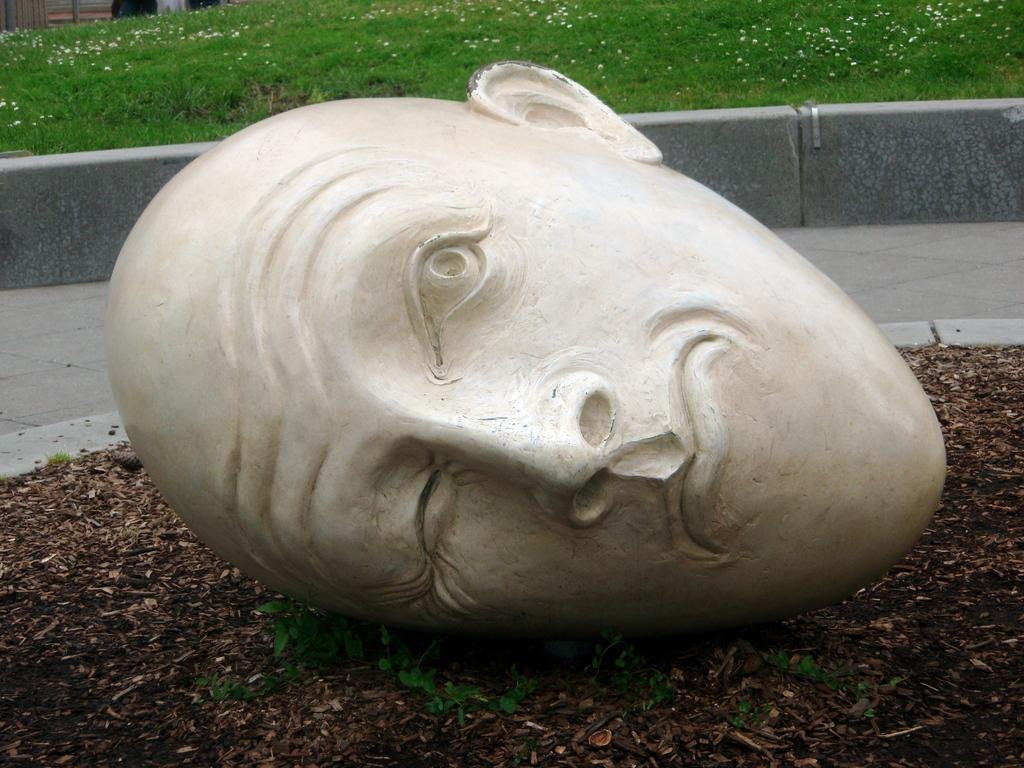What type of artwork is present in the image? There is a clay face sculpture in the image. Where is the sculpture located? The sculpture is on the ground. What can be seen in the background of the image? There is grass visible in the background of the image. Is there a patch of water visible near the sculpture in the image? There is no patch of water visible in the image; only grass is mentioned in the background. 